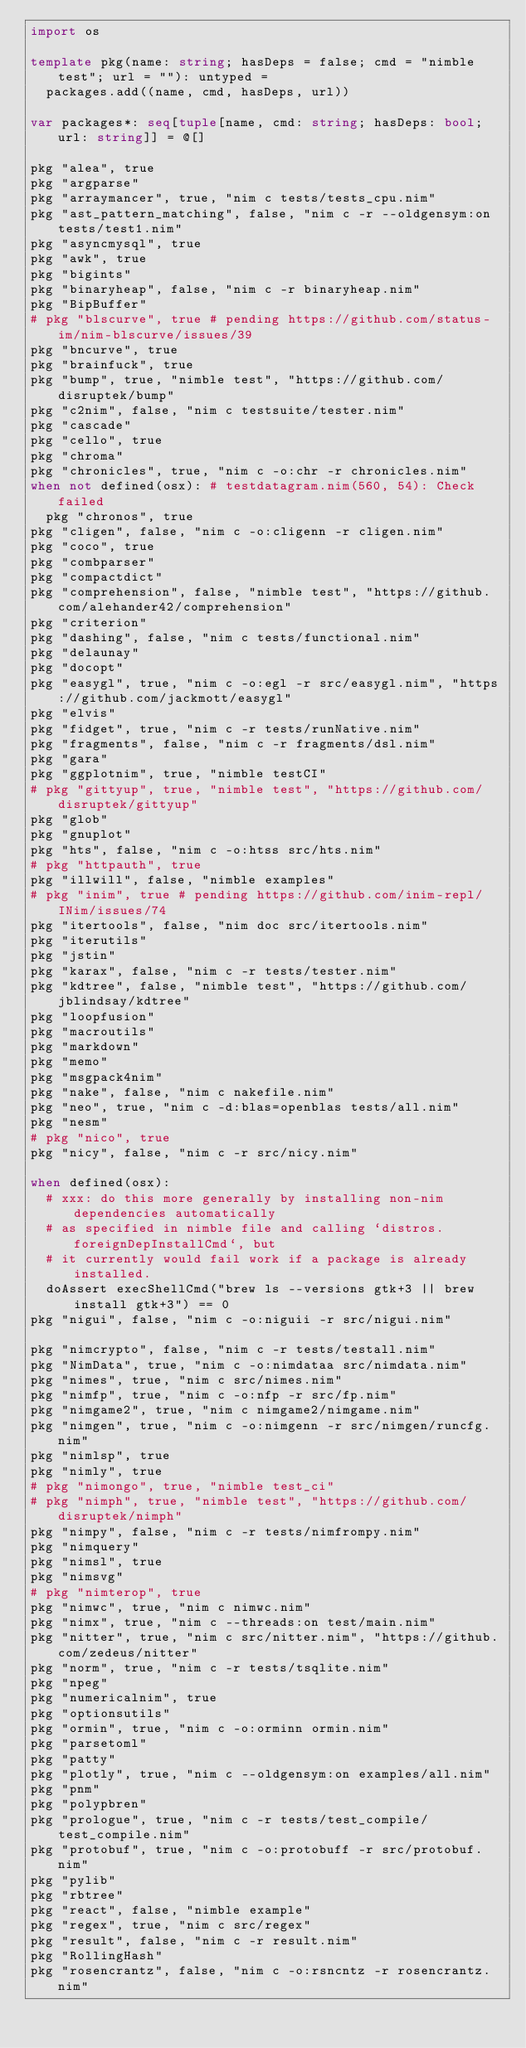Convert code to text. <code><loc_0><loc_0><loc_500><loc_500><_Nim_>import os

template pkg(name: string; hasDeps = false; cmd = "nimble test"; url = ""): untyped =
  packages.add((name, cmd, hasDeps, url))

var packages*: seq[tuple[name, cmd: string; hasDeps: bool; url: string]] = @[]

pkg "alea", true
pkg "argparse"
pkg "arraymancer", true, "nim c tests/tests_cpu.nim"
pkg "ast_pattern_matching", false, "nim c -r --oldgensym:on tests/test1.nim"
pkg "asyncmysql", true
pkg "awk", true
pkg "bigints"
pkg "binaryheap", false, "nim c -r binaryheap.nim"
pkg "BipBuffer"
# pkg "blscurve", true # pending https://github.com/status-im/nim-blscurve/issues/39
pkg "bncurve", true
pkg "brainfuck", true
pkg "bump", true, "nimble test", "https://github.com/disruptek/bump"
pkg "c2nim", false, "nim c testsuite/tester.nim"
pkg "cascade"
pkg "cello", true
pkg "chroma"
pkg "chronicles", true, "nim c -o:chr -r chronicles.nim"
when not defined(osx): # testdatagram.nim(560, 54): Check failed
  pkg "chronos", true
pkg "cligen", false, "nim c -o:cligenn -r cligen.nim"
pkg "coco", true
pkg "combparser"
pkg "compactdict"
pkg "comprehension", false, "nimble test", "https://github.com/alehander42/comprehension"
pkg "criterion"
pkg "dashing", false, "nim c tests/functional.nim"
pkg "delaunay"
pkg "docopt"
pkg "easygl", true, "nim c -o:egl -r src/easygl.nim", "https://github.com/jackmott/easygl"
pkg "elvis"
pkg "fidget", true, "nim c -r tests/runNative.nim"
pkg "fragments", false, "nim c -r fragments/dsl.nim"
pkg "gara"
pkg "ggplotnim", true, "nimble testCI"
# pkg "gittyup", true, "nimble test", "https://github.com/disruptek/gittyup"
pkg "glob"
pkg "gnuplot"
pkg "hts", false, "nim c -o:htss src/hts.nim"
# pkg "httpauth", true
pkg "illwill", false, "nimble examples"
# pkg "inim", true # pending https://github.com/inim-repl/INim/issues/74
pkg "itertools", false, "nim doc src/itertools.nim"
pkg "iterutils"
pkg "jstin"
pkg "karax", false, "nim c -r tests/tester.nim"
pkg "kdtree", false, "nimble test", "https://github.com/jblindsay/kdtree"
pkg "loopfusion"
pkg "macroutils"
pkg "markdown"
pkg "memo"
pkg "msgpack4nim"
pkg "nake", false, "nim c nakefile.nim"
pkg "neo", true, "nim c -d:blas=openblas tests/all.nim"
pkg "nesm"
# pkg "nico", true
pkg "nicy", false, "nim c -r src/nicy.nim"

when defined(osx):
  # xxx: do this more generally by installing non-nim dependencies automatically
  # as specified in nimble file and calling `distros.foreignDepInstallCmd`, but
  # it currently would fail work if a package is already installed.
  doAssert execShellCmd("brew ls --versions gtk+3 || brew install gtk+3") == 0
pkg "nigui", false, "nim c -o:niguii -r src/nigui.nim"

pkg "nimcrypto", false, "nim c -r tests/testall.nim"
pkg "NimData", true, "nim c -o:nimdataa src/nimdata.nim"
pkg "nimes", true, "nim c src/nimes.nim"
pkg "nimfp", true, "nim c -o:nfp -r src/fp.nim"
pkg "nimgame2", true, "nim c nimgame2/nimgame.nim"
pkg "nimgen", true, "nim c -o:nimgenn -r src/nimgen/runcfg.nim"
pkg "nimlsp", true
pkg "nimly", true
# pkg "nimongo", true, "nimble test_ci"
# pkg "nimph", true, "nimble test", "https://github.com/disruptek/nimph"
pkg "nimpy", false, "nim c -r tests/nimfrompy.nim"
pkg "nimquery"
pkg "nimsl", true
pkg "nimsvg"
# pkg "nimterop", true
pkg "nimwc", true, "nim c nimwc.nim"
pkg "nimx", true, "nim c --threads:on test/main.nim"
pkg "nitter", true, "nim c src/nitter.nim", "https://github.com/zedeus/nitter"
pkg "norm", true, "nim c -r tests/tsqlite.nim"
pkg "npeg"
pkg "numericalnim", true
pkg "optionsutils"
pkg "ormin", true, "nim c -o:orminn ormin.nim"
pkg "parsetoml"
pkg "patty"
pkg "plotly", true, "nim c --oldgensym:on examples/all.nim"
pkg "pnm"
pkg "polypbren"
pkg "prologue", true, "nim c -r tests/test_compile/test_compile.nim"
pkg "protobuf", true, "nim c -o:protobuff -r src/protobuf.nim"
pkg "pylib"
pkg "rbtree"
pkg "react", false, "nimble example"
pkg "regex", true, "nim c src/regex"
pkg "result", false, "nim c -r result.nim"
pkg "RollingHash"
pkg "rosencrantz", false, "nim c -o:rsncntz -r rosencrantz.nim"</code> 